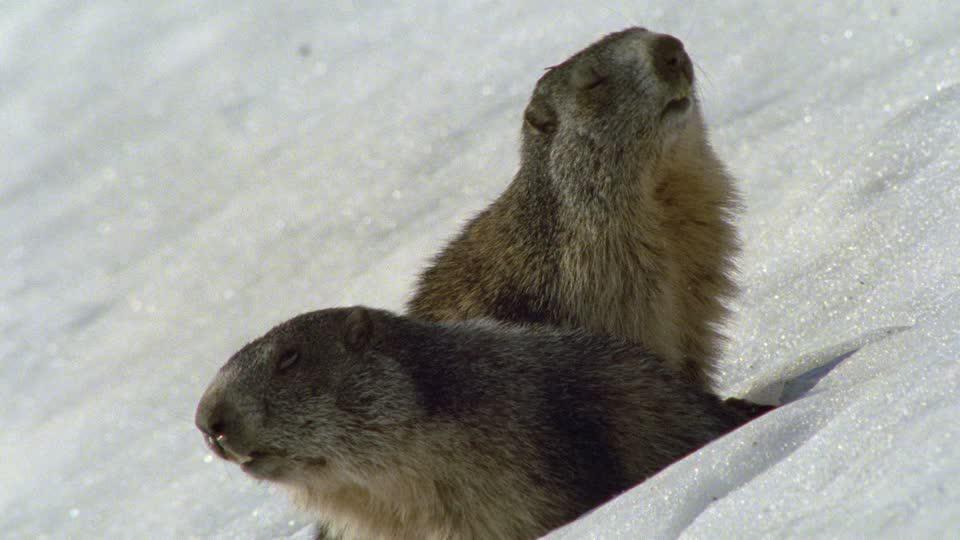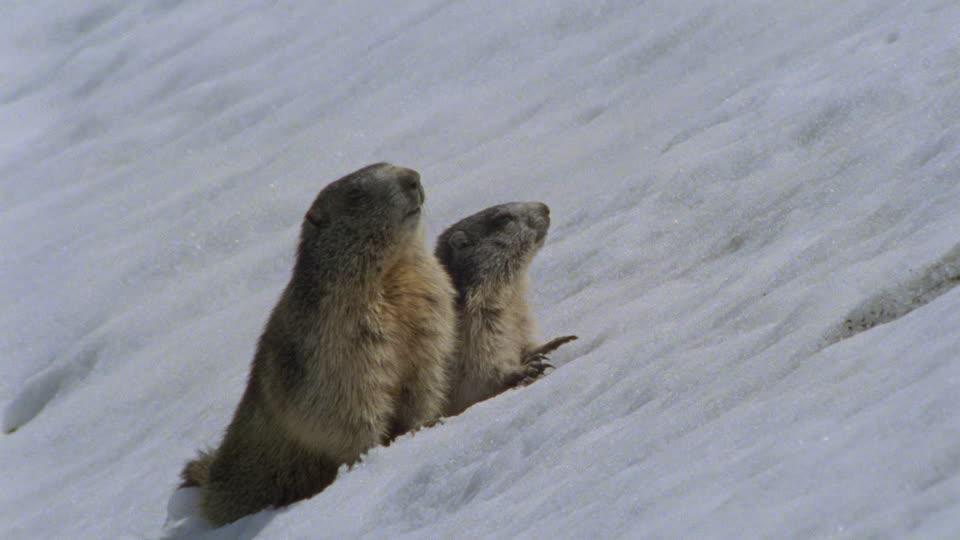The first image is the image on the left, the second image is the image on the right. Evaluate the accuracy of this statement regarding the images: "The left image contains exactly one rodent in the snow.". Is it true? Answer yes or no. No. The first image is the image on the left, the second image is the image on the right. Considering the images on both sides, is "An image shows a single close-mouthed marmot poking its head up out of the snow." valid? Answer yes or no. No. 